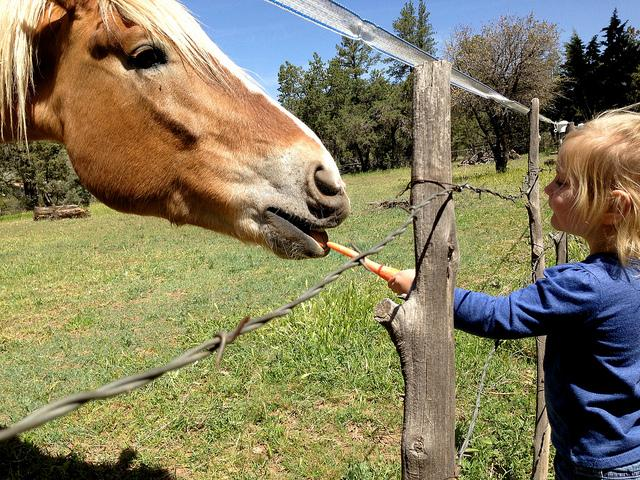What vegetable is toxic to horses? Please explain your reasoning. tomatoes. The plant contains an alkaloid that slows gut function. 